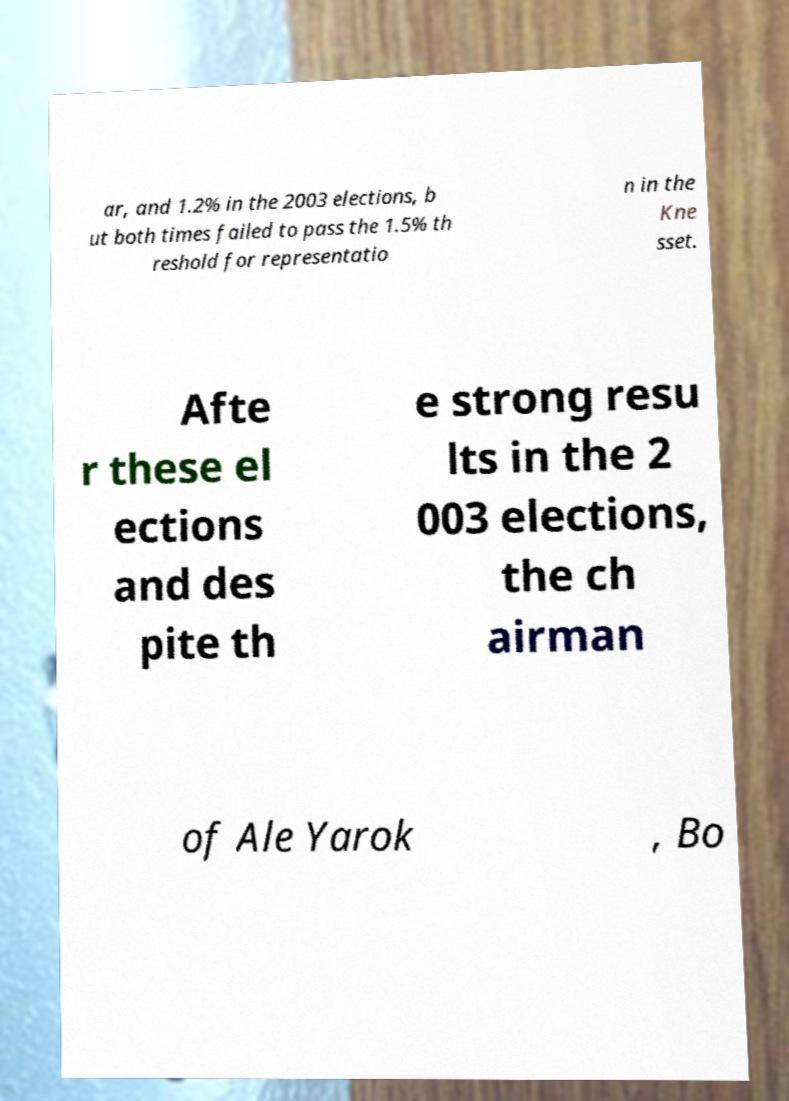Can you read and provide the text displayed in the image?This photo seems to have some interesting text. Can you extract and type it out for me? ar, and 1.2% in the 2003 elections, b ut both times failed to pass the 1.5% th reshold for representatio n in the Kne sset. Afte r these el ections and des pite th e strong resu lts in the 2 003 elections, the ch airman of Ale Yarok , Bo 